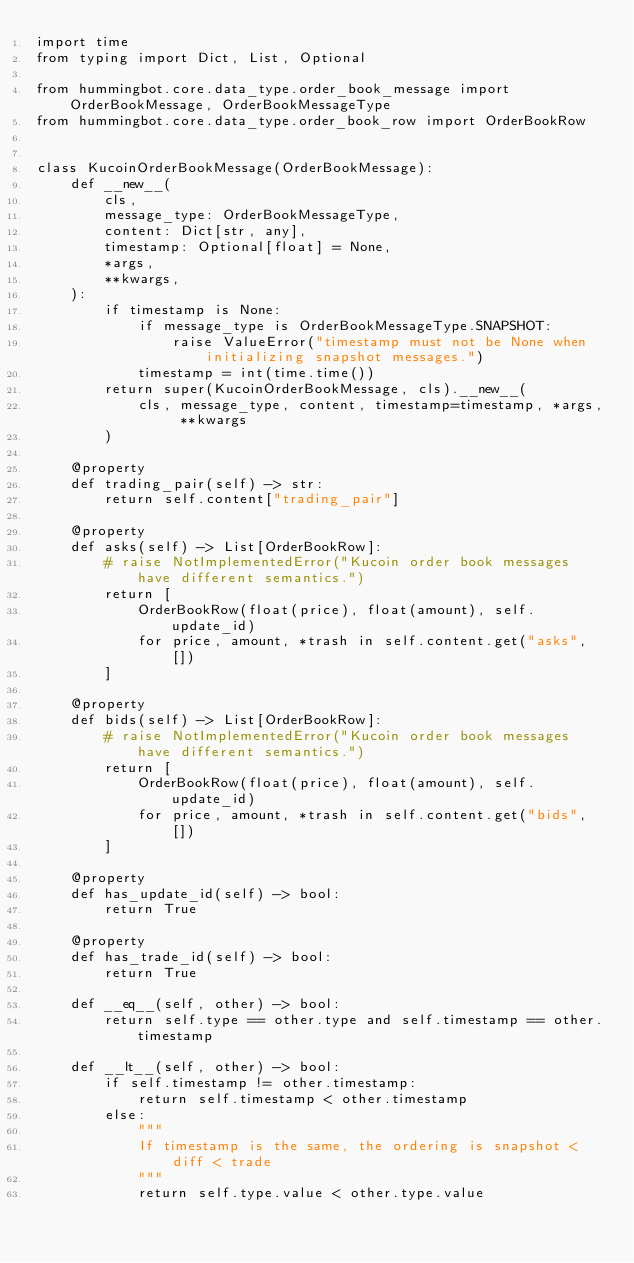<code> <loc_0><loc_0><loc_500><loc_500><_Python_>import time
from typing import Dict, List, Optional

from hummingbot.core.data_type.order_book_message import OrderBookMessage, OrderBookMessageType
from hummingbot.core.data_type.order_book_row import OrderBookRow


class KucoinOrderBookMessage(OrderBookMessage):
    def __new__(
        cls,
        message_type: OrderBookMessageType,
        content: Dict[str, any],
        timestamp: Optional[float] = None,
        *args,
        **kwargs,
    ):
        if timestamp is None:
            if message_type is OrderBookMessageType.SNAPSHOT:
                raise ValueError("timestamp must not be None when initializing snapshot messages.")
            timestamp = int(time.time())
        return super(KucoinOrderBookMessage, cls).__new__(
            cls, message_type, content, timestamp=timestamp, *args, **kwargs
        )

    @property
    def trading_pair(self) -> str:
        return self.content["trading_pair"]

    @property
    def asks(self) -> List[OrderBookRow]:
        # raise NotImplementedError("Kucoin order book messages have different semantics.")
        return [
            OrderBookRow(float(price), float(amount), self.update_id)
            for price, amount, *trash in self.content.get("asks", [])
        ]

    @property
    def bids(self) -> List[OrderBookRow]:
        # raise NotImplementedError("Kucoin order book messages have different semantics.")
        return [
            OrderBookRow(float(price), float(amount), self.update_id)
            for price, amount, *trash in self.content.get("bids", [])
        ]

    @property
    def has_update_id(self) -> bool:
        return True

    @property
    def has_trade_id(self) -> bool:
        return True

    def __eq__(self, other) -> bool:
        return self.type == other.type and self.timestamp == other.timestamp

    def __lt__(self, other) -> bool:
        if self.timestamp != other.timestamp:
            return self.timestamp < other.timestamp
        else:
            """
            If timestamp is the same, the ordering is snapshot < diff < trade
            """
            return self.type.value < other.type.value
</code> 